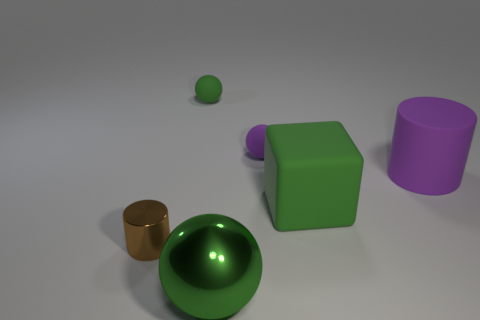Add 3 large cyan balls. How many objects exist? 9 Subtract all tiny balls. How many balls are left? 1 Subtract all purple spheres. How many spheres are left? 2 Subtract 2 spheres. How many spheres are left? 1 Subtract all purple cylinders. How many green spheres are left? 2 Subtract all large blue shiny balls. Subtract all tiny objects. How many objects are left? 3 Add 3 green rubber things. How many green rubber things are left? 5 Add 4 large metallic spheres. How many large metallic spheres exist? 5 Subtract 0 blue cubes. How many objects are left? 6 Subtract all cylinders. How many objects are left? 4 